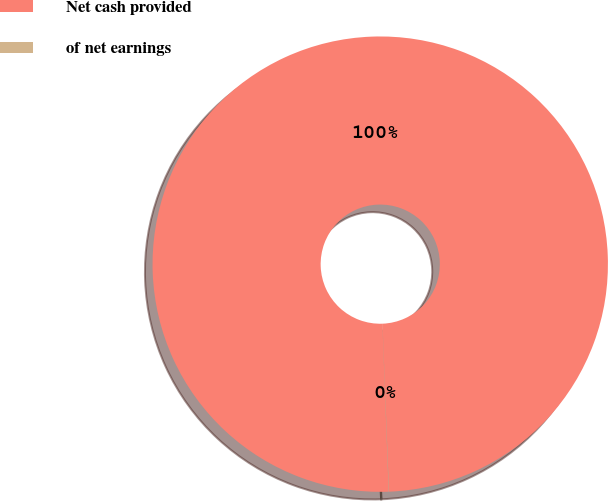Convert chart. <chart><loc_0><loc_0><loc_500><loc_500><pie_chart><fcel>Net cash provided<fcel>of net earnings<nl><fcel>99.98%<fcel>0.02%<nl></chart> 